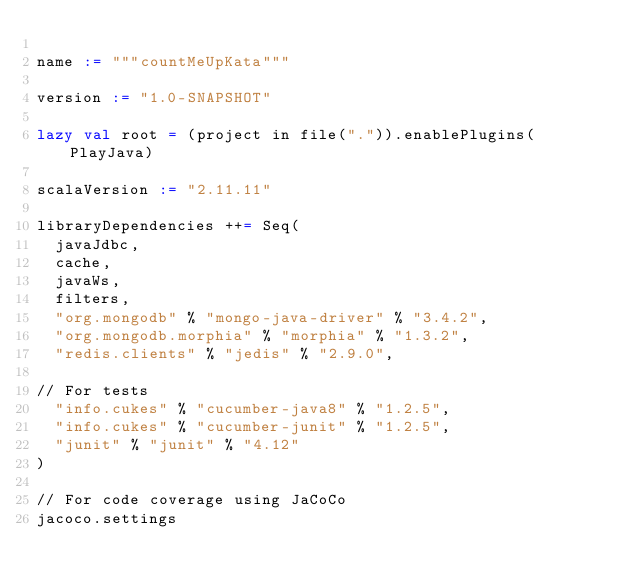Convert code to text. <code><loc_0><loc_0><loc_500><loc_500><_Scala_>
name := """countMeUpKata"""

version := "1.0-SNAPSHOT"

lazy val root = (project in file(".")).enablePlugins(PlayJava)

scalaVersion := "2.11.11"

libraryDependencies ++= Seq(
  javaJdbc,
  cache,
  javaWs,
  filters,
  "org.mongodb" % "mongo-java-driver" % "3.4.2",
  "org.mongodb.morphia" % "morphia" % "1.3.2",
  "redis.clients" % "jedis" % "2.9.0",

// For tests
  "info.cukes" % "cucumber-java8" % "1.2.5",
  "info.cukes" % "cucumber-junit" % "1.2.5",
  "junit" % "junit" % "4.12"
)

// For code coverage using JaCoCo
jacoco.settings
</code> 